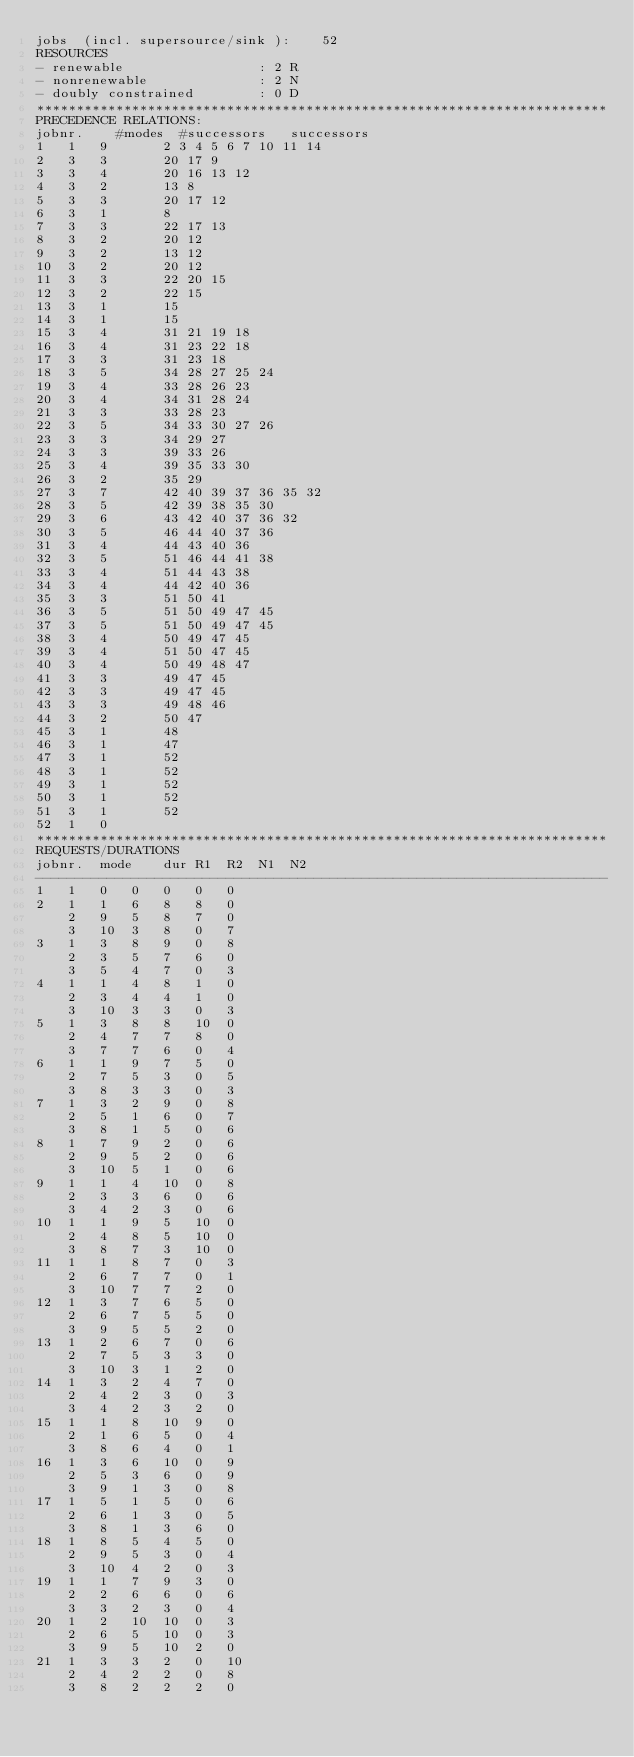Convert code to text. <code><loc_0><loc_0><loc_500><loc_500><_ObjectiveC_>jobs  (incl. supersource/sink ):	52
RESOURCES
- renewable                 : 2 R
- nonrenewable              : 2 N
- doubly constrained        : 0 D
************************************************************************
PRECEDENCE RELATIONS:
jobnr.    #modes  #successors   successors
1	1	9		2 3 4 5 6 7 10 11 14 
2	3	3		20 17 9 
3	3	4		20 16 13 12 
4	3	2		13 8 
5	3	3		20 17 12 
6	3	1		8 
7	3	3		22 17 13 
8	3	2		20 12 
9	3	2		13 12 
10	3	2		20 12 
11	3	3		22 20 15 
12	3	2		22 15 
13	3	1		15 
14	3	1		15 
15	3	4		31 21 19 18 
16	3	4		31 23 22 18 
17	3	3		31 23 18 
18	3	5		34 28 27 25 24 
19	3	4		33 28 26 23 
20	3	4		34 31 28 24 
21	3	3		33 28 23 
22	3	5		34 33 30 27 26 
23	3	3		34 29 27 
24	3	3		39 33 26 
25	3	4		39 35 33 30 
26	3	2		35 29 
27	3	7		42 40 39 37 36 35 32 
28	3	5		42 39 38 35 30 
29	3	6		43 42 40 37 36 32 
30	3	5		46 44 40 37 36 
31	3	4		44 43 40 36 
32	3	5		51 46 44 41 38 
33	3	4		51 44 43 38 
34	3	4		44 42 40 36 
35	3	3		51 50 41 
36	3	5		51 50 49 47 45 
37	3	5		51 50 49 47 45 
38	3	4		50 49 47 45 
39	3	4		51 50 47 45 
40	3	4		50 49 48 47 
41	3	3		49 47 45 
42	3	3		49 47 45 
43	3	3		49 48 46 
44	3	2		50 47 
45	3	1		48 
46	3	1		47 
47	3	1		52 
48	3	1		52 
49	3	1		52 
50	3	1		52 
51	3	1		52 
52	1	0		
************************************************************************
REQUESTS/DURATIONS
jobnr.	mode	dur	R1	R2	N1	N2	
------------------------------------------------------------------------
1	1	0	0	0	0	0	
2	1	1	6	8	8	0	
	2	9	5	8	7	0	
	3	10	3	8	0	7	
3	1	3	8	9	0	8	
	2	3	5	7	6	0	
	3	5	4	7	0	3	
4	1	1	4	8	1	0	
	2	3	4	4	1	0	
	3	10	3	3	0	3	
5	1	3	8	8	10	0	
	2	4	7	7	8	0	
	3	7	7	6	0	4	
6	1	1	9	7	5	0	
	2	7	5	3	0	5	
	3	8	3	3	0	3	
7	1	3	2	9	0	8	
	2	5	1	6	0	7	
	3	8	1	5	0	6	
8	1	7	9	2	0	6	
	2	9	5	2	0	6	
	3	10	5	1	0	6	
9	1	1	4	10	0	8	
	2	3	3	6	0	6	
	3	4	2	3	0	6	
10	1	1	9	5	10	0	
	2	4	8	5	10	0	
	3	8	7	3	10	0	
11	1	1	8	7	0	3	
	2	6	7	7	0	1	
	3	10	7	7	2	0	
12	1	3	7	6	5	0	
	2	6	7	5	5	0	
	3	9	5	5	2	0	
13	1	2	6	7	0	6	
	2	7	5	3	3	0	
	3	10	3	1	2	0	
14	1	3	2	4	7	0	
	2	4	2	3	0	3	
	3	4	2	3	2	0	
15	1	1	8	10	9	0	
	2	1	6	5	0	4	
	3	8	6	4	0	1	
16	1	3	6	10	0	9	
	2	5	3	6	0	9	
	3	9	1	3	0	8	
17	1	5	1	5	0	6	
	2	6	1	3	0	5	
	3	8	1	3	6	0	
18	1	8	5	4	5	0	
	2	9	5	3	0	4	
	3	10	4	2	0	3	
19	1	1	7	9	3	0	
	2	2	6	6	0	6	
	3	3	2	3	0	4	
20	1	2	10	10	0	3	
	2	6	5	10	0	3	
	3	9	5	10	2	0	
21	1	3	3	2	0	10	
	2	4	2	2	0	8	
	3	8	2	2	2	0	</code> 